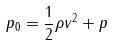Convert formula to latex. <formula><loc_0><loc_0><loc_500><loc_500>p _ { 0 } = \frac { 1 } { 2 } \rho v ^ { 2 } + p</formula> 